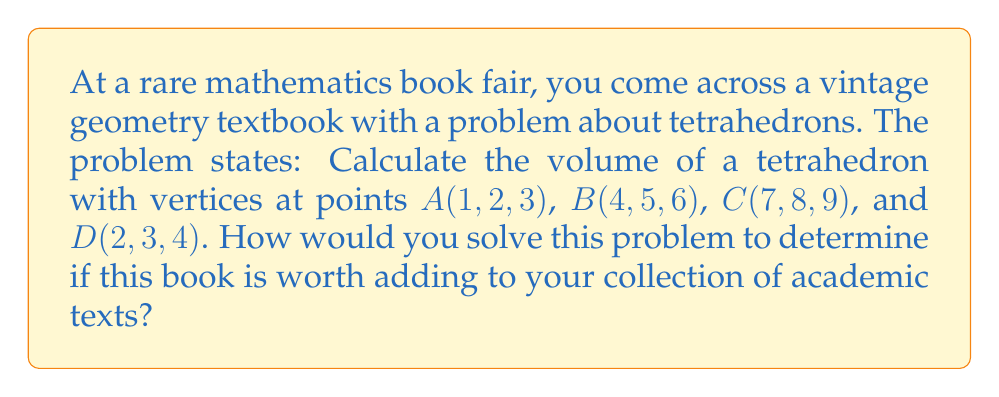Can you solve this math problem? To solve this problem, we'll use the following steps:

1) The volume of a tetrahedron can be calculated using the determinant method:

   $$V = \frac{1}{6}\left|\det\begin{pmatrix}
   x_1 & y_1 & z_1 & 1 \\
   x_2 & y_2 & z_2 & 1 \\
   x_3 & y_3 & z_3 & 1 \\
   x_4 & y_4 & z_4 & 1
   \end{pmatrix}\right|$$

   where $(x_i, y_i, z_i)$ are the coordinates of the $i$-th vertex.

2) Substitute the given coordinates into the determinant:

   $$V = \frac{1}{6}\left|\det\begin{pmatrix}
   1 & 2 & 3 & 1 \\
   4 & 5 & 6 & 1 \\
   7 & 8 & 9 & 1 \\
   2 & 3 & 4 & 1
   \end{pmatrix}\right|$$

3) Calculate the determinant using the Laplace expansion along the first column:

   $$\begin{align}
   \det &= 1\cdot\begin{vmatrix}5&6&1\\8&9&1\\3&4&1\end{vmatrix} - 4\cdot\begin{vmatrix}2&3&1\\8&9&1\\3&4&1\end{vmatrix} + 7\cdot\begin{vmatrix}2&3&1\\5&6&1\\3&4&1\end{vmatrix} - 2\cdot\begin{vmatrix}2&3&1\\5&6&1\\8&9&1\end{vmatrix} \\
   &= 1(5-6) - 4(-1) + 7(2) - 2(3) \\
   &= -1 + 4 + 14 - 6 \\
   &= 11
   \end{align}$$

4) Substitute this value into the volume formula:

   $$V = \frac{1}{6} \cdot 11 = \frac{11}{6}$$

Therefore, the volume of the tetrahedron is $\frac{11}{6}$ cubic units.
Answer: $\frac{11}{6}$ cubic units 